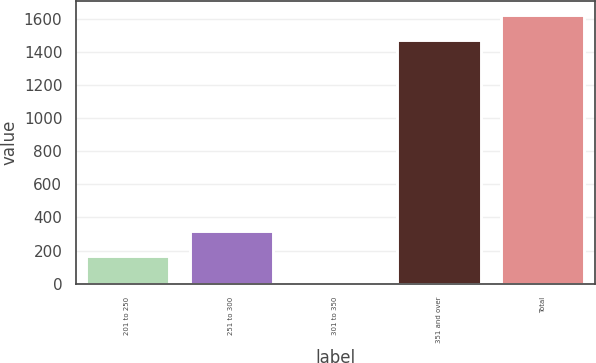Convert chart to OTSL. <chart><loc_0><loc_0><loc_500><loc_500><bar_chart><fcel>201 to 250<fcel>251 to 300<fcel>301 to 350<fcel>351 and over<fcel>Total<nl><fcel>165.41<fcel>319.92<fcel>10.9<fcel>1469.3<fcel>1623.81<nl></chart> 